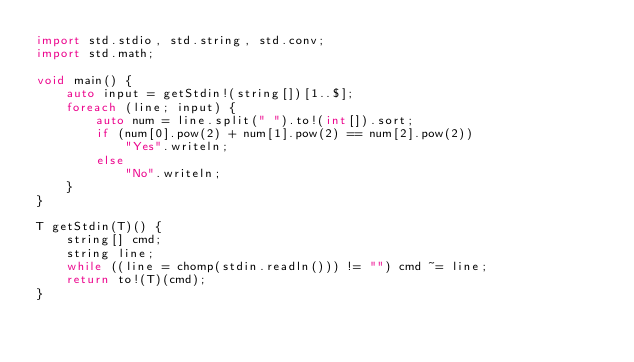<code> <loc_0><loc_0><loc_500><loc_500><_D_>import std.stdio, std.string, std.conv;
import std.math;

void main() {
    auto input = getStdin!(string[])[1..$];
    foreach (line; input) {
    	auto num = line.split(" ").to!(int[]).sort;
    	if (num[0].pow(2) + num[1].pow(2) == num[2].pow(2))
    		"Yes".writeln;
    	else
    		"No".writeln;
    }
}

T getStdin(T)() {
    string[] cmd;
    string line;
    while ((line = chomp(stdin.readln())) != "") cmd ~= line;
    return to!(T)(cmd);
}</code> 